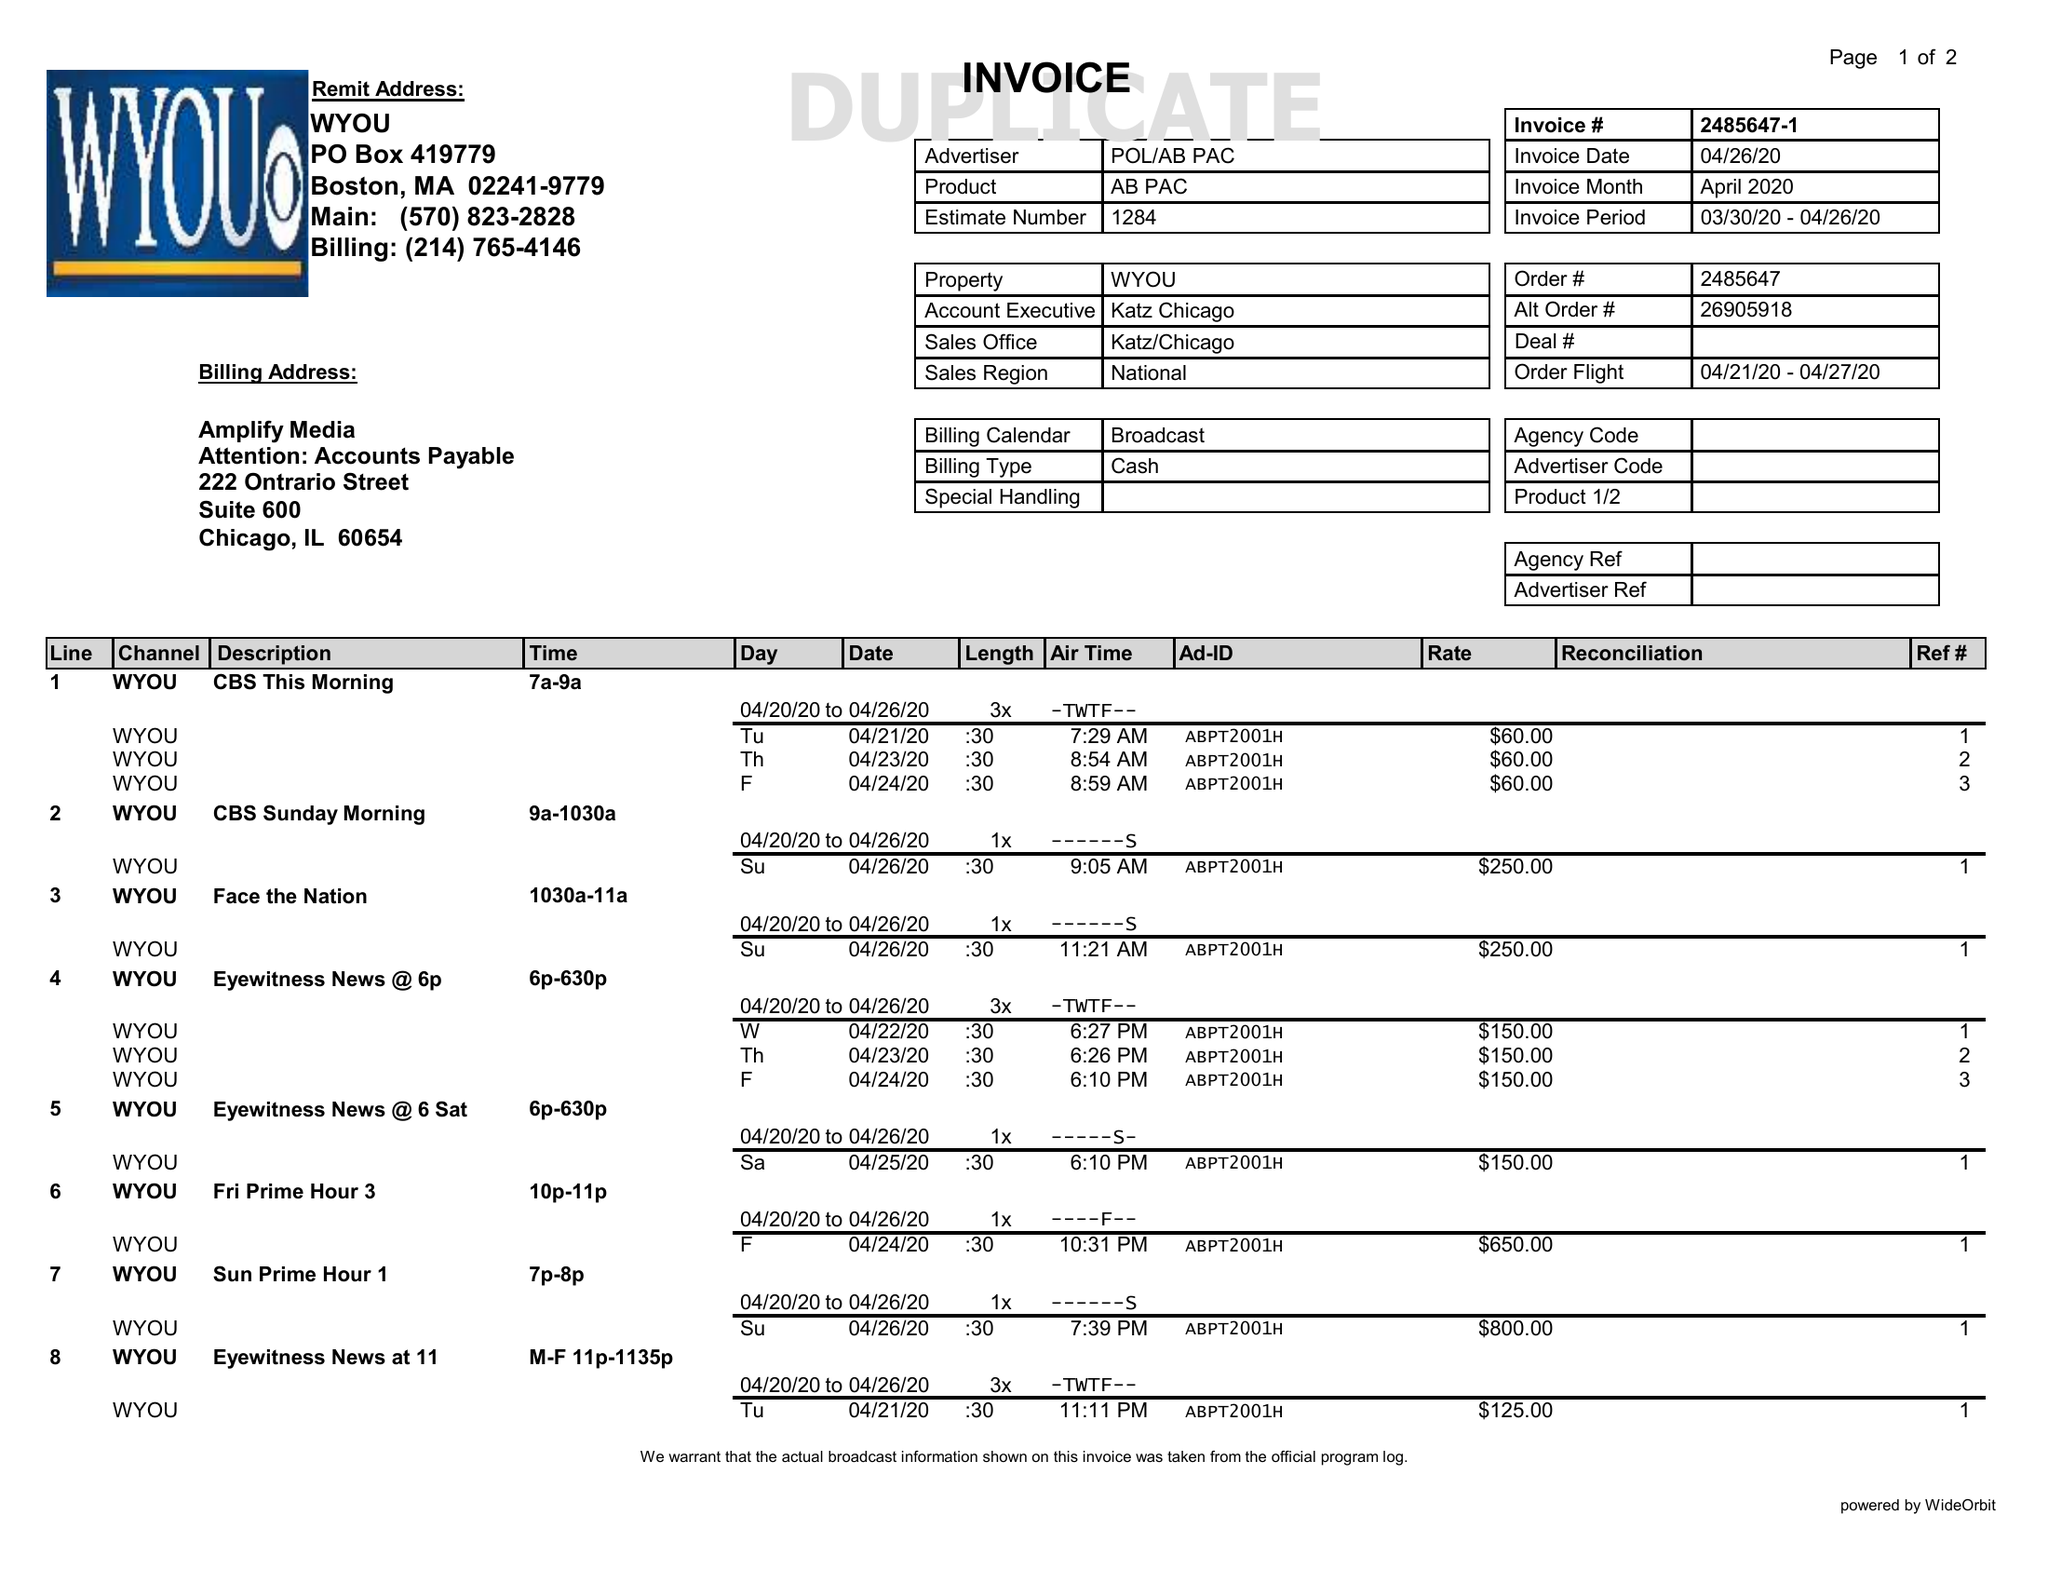What is the value for the contract_num?
Answer the question using a single word or phrase. 2485647 